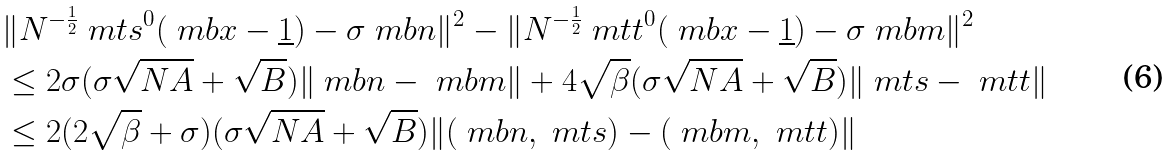Convert formula to latex. <formula><loc_0><loc_0><loc_500><loc_500>& \| N ^ { - \frac { 1 } { 2 } } \ m t s ^ { 0 } ( \ m b x - \underline { 1 } ) - \sigma \ m b n \| ^ { 2 } - \| N ^ { - \frac { 1 } { 2 } } \ m t t ^ { 0 } ( \ m b x - \underline { 1 } ) - \sigma \ m b m \| ^ { 2 } \\ & \leq 2 \sigma ( \sigma \sqrt { N A } + \sqrt { B } ) \| \ m b n - \ m b m \| + 4 \sqrt { \beta } ( \sigma \sqrt { N A } + \sqrt { B } ) \| \ m t s - \ m t t \| \\ & \leq 2 ( 2 \sqrt { \beta } + \sigma ) ( \sigma \sqrt { N A } + \sqrt { B } ) \| ( \ m b n , \ m t s ) - ( \ m b m , \ m t t ) \|</formula> 